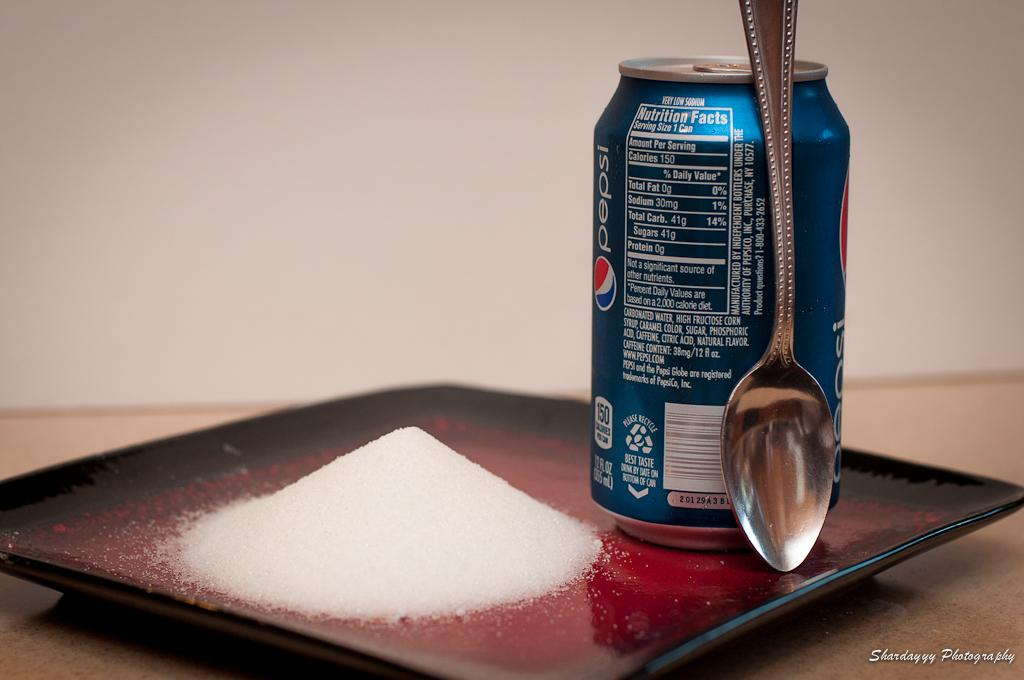<image>
Create a compact narrative representing the image presented. Photo of a can, a spoon, and sugar, demonstrating the amount of sugar in a Pepsi. 